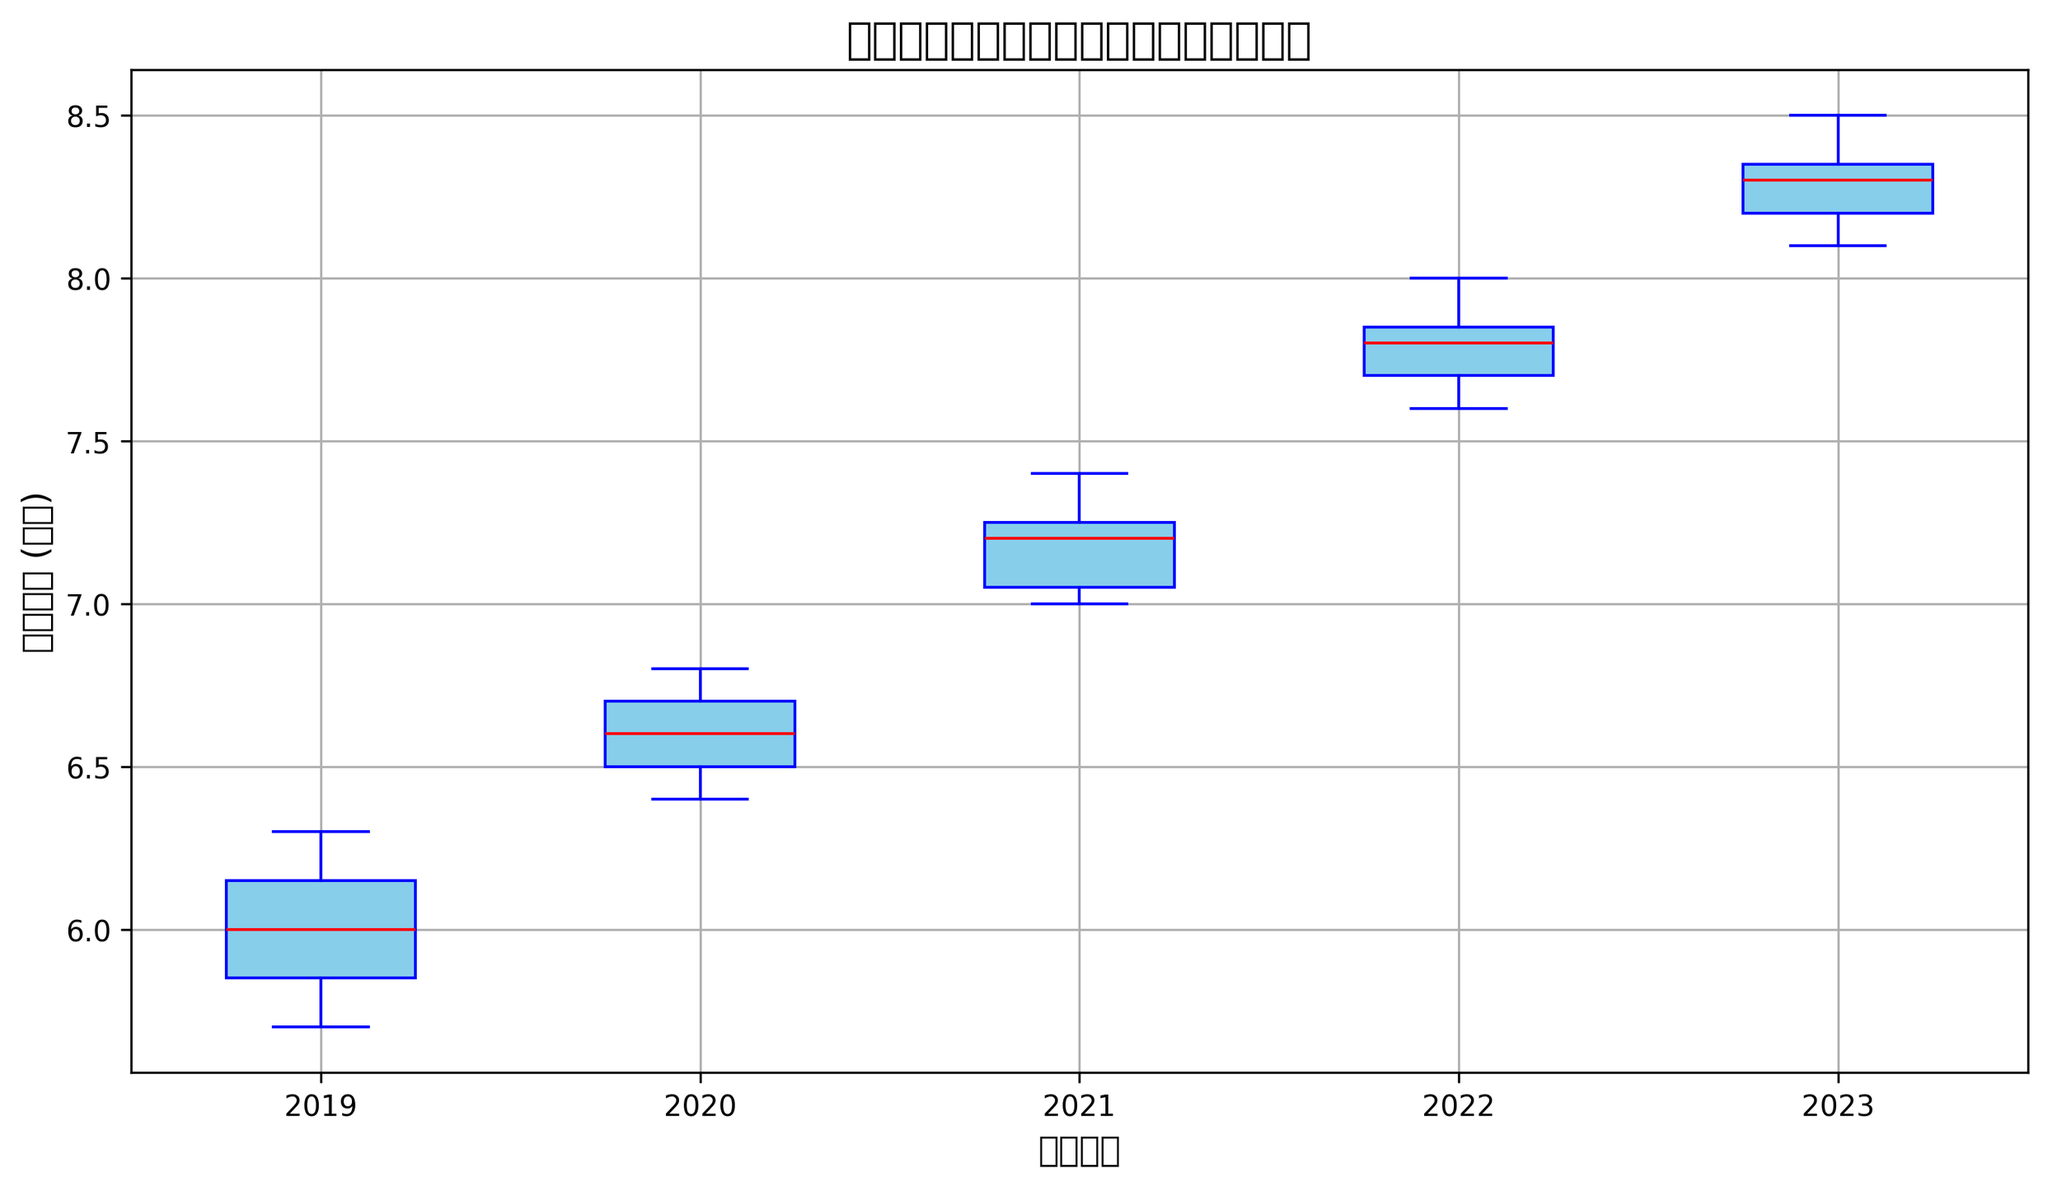什么年份的折叠屏手机电池寿命中位数最高？ 从图中看，可以比较不同年份的电池寿命箱线图中的红色中位数线的位置。2023年的中位数线最高。
Answer: 2023 2019年与2020年的折叠屏手机电池寿命中位数相差多少？ 从图中找到2019年和2020年电池寿命箱线图中的红色中位数线，分别看到它们的位置，计算差值即可。2019年的中位数约为6.0小时，2020年的中位数约为6.6小时。差值是6.6 - 6.0 = 0.6小时。
Answer: 0.6小时 哪个年份的折叠屏手机电池寿命波动范围最小？ 要判断哪个年份的电池寿命波动范围最小，可以看箱线图的盒子和须线的总长度，即上下四分位数的范围。2023年的波动范围最小，因为2023年的盒子和须线长度最短。
Answer: 2023 2022年折叠屏手机电池寿命的下四分位数和上四分位数分别是多少？ 在图中找到2022年的箱线图，下四分位数是盒子的下边缘位置，上四分位数是盒子的上边缘位置。下四分位数大约是7.7小时，上四分位数大约是7.8小时。
Answer: 7.7小时和7.8小时 哪一年份的折叠屏手机电池寿命上须线（最大值）最高？ 看各年的电池寿命箱线图，比较上须线的位置，电池寿命最长的年份的上须线最高。2023年的上须线最高。
Answer: 2023 2021年折叠屏手机电池寿命的范围（最大值和最小值之间的差值）是多少？ 找到2021年箱线图的上须线和下须线位置，看看两个值之间的差距。2021年的最高值大约是7.4小时，最低值大约是7.0小时。差值是7.4 - 7.0 = 0.4小时。
Answer: 0.4小时 不同年份的折叠屏手机电池寿命中，有没有一年有明显的离群值？ 查找图中是否有任何一年有明显超出上须线或下须线的单独点。此处并没有任何一年有明显离群值的点出现。
Answer: 没有 